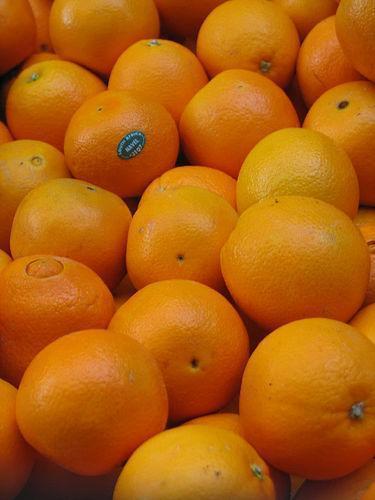How many oranges have a sticker on it?
Give a very brief answer. 1. How many oranges are in the picture?
Give a very brief answer. 14. How many bottles on the cutting board are uncorked?
Give a very brief answer. 0. 